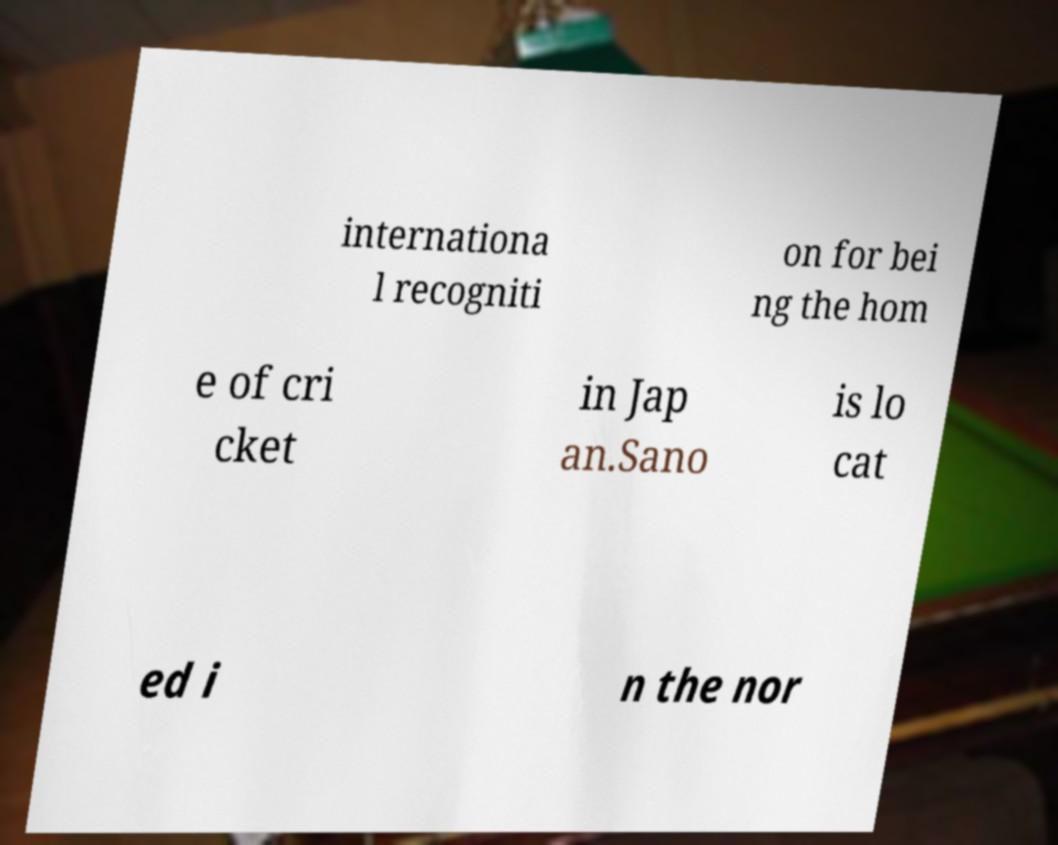Please identify and transcribe the text found in this image. internationa l recogniti on for bei ng the hom e of cri cket in Jap an.Sano is lo cat ed i n the nor 